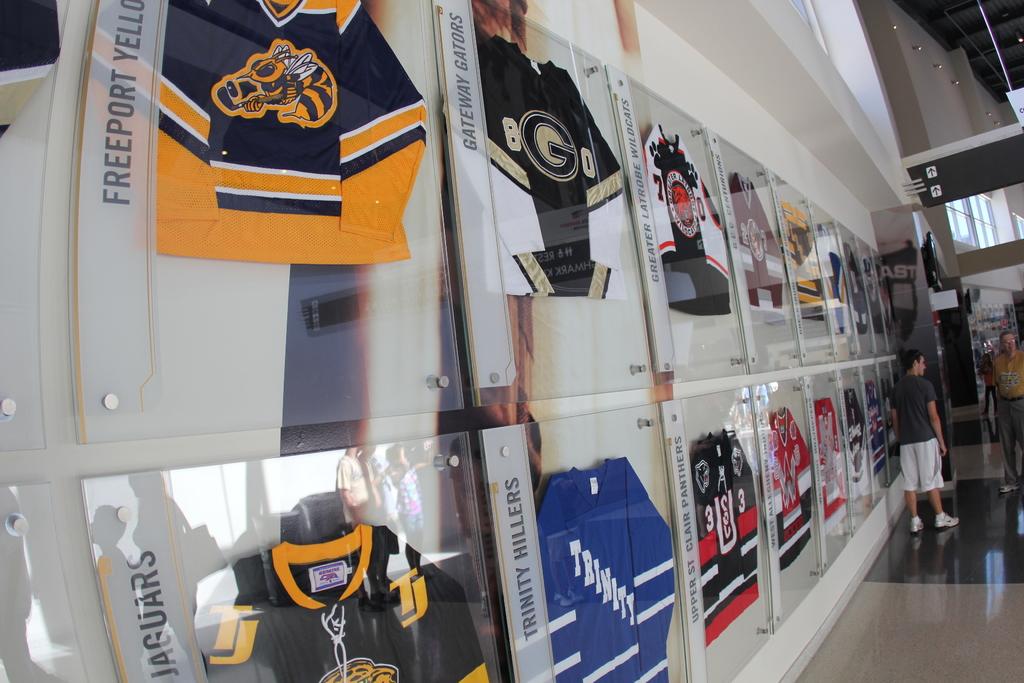What color follows freeport?
Provide a short and direct response. Yellow. What team is wrote below freeport?
Offer a terse response. Jaguars. 